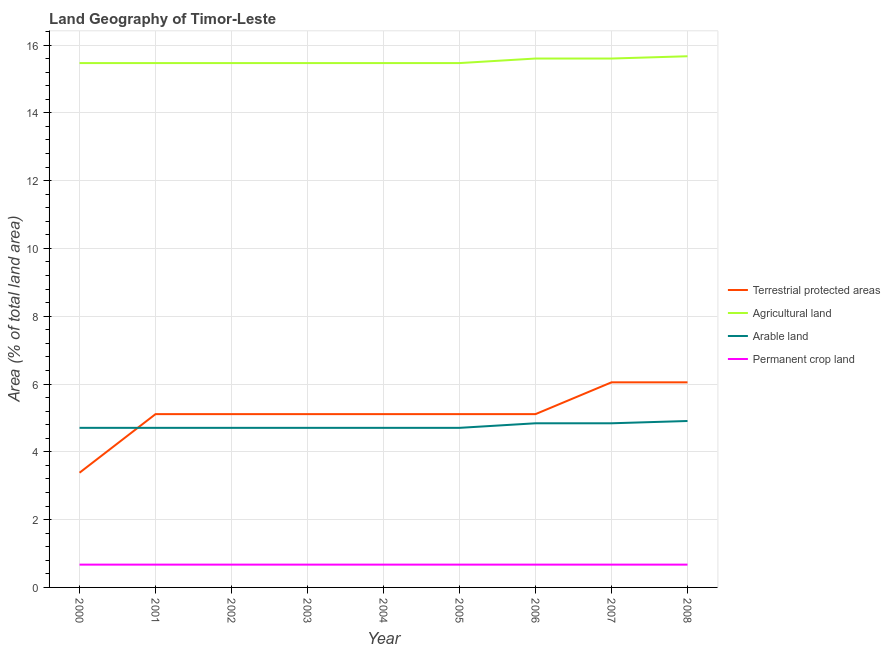How many different coloured lines are there?
Make the answer very short. 4. Is the number of lines equal to the number of legend labels?
Provide a succinct answer. Yes. What is the percentage of area under permanent crop land in 2001?
Your response must be concise. 0.67. Across all years, what is the maximum percentage of area under arable land?
Your response must be concise. 4.91. Across all years, what is the minimum percentage of area under agricultural land?
Give a very brief answer. 15.47. In which year was the percentage of land under terrestrial protection maximum?
Give a very brief answer. 2007. What is the total percentage of land under terrestrial protection in the graph?
Make the answer very short. 46.16. What is the difference between the percentage of land under terrestrial protection in 2000 and that in 2006?
Provide a short and direct response. -1.73. What is the difference between the percentage of area under permanent crop land in 2004 and the percentage of land under terrestrial protection in 2005?
Offer a terse response. -4.44. What is the average percentage of area under permanent crop land per year?
Your response must be concise. 0.67. In the year 2000, what is the difference between the percentage of area under arable land and percentage of area under permanent crop land?
Offer a very short reply. 4.03. What is the ratio of the percentage of area under agricultural land in 2007 to that in 2008?
Ensure brevity in your answer.  1. Is the percentage of area under permanent crop land in 2002 less than that in 2006?
Offer a terse response. No. Is the difference between the percentage of land under terrestrial protection in 2001 and 2005 greater than the difference between the percentage of area under agricultural land in 2001 and 2005?
Your response must be concise. No. What is the difference between the highest and the second highest percentage of area under permanent crop land?
Provide a succinct answer. 0. What is the difference between the highest and the lowest percentage of area under agricultural land?
Keep it short and to the point. 0.2. In how many years, is the percentage of area under permanent crop land greater than the average percentage of area under permanent crop land taken over all years?
Provide a short and direct response. 0. Is it the case that in every year, the sum of the percentage of area under arable land and percentage of land under terrestrial protection is greater than the sum of percentage of area under permanent crop land and percentage of area under agricultural land?
Your answer should be very brief. No. Is the percentage of area under agricultural land strictly greater than the percentage of land under terrestrial protection over the years?
Your answer should be compact. Yes. How many lines are there?
Provide a short and direct response. 4. How many years are there in the graph?
Give a very brief answer. 9. Are the values on the major ticks of Y-axis written in scientific E-notation?
Your answer should be very brief. No. Where does the legend appear in the graph?
Make the answer very short. Center right. How many legend labels are there?
Provide a short and direct response. 4. How are the legend labels stacked?
Offer a very short reply. Vertical. What is the title of the graph?
Your answer should be compact. Land Geography of Timor-Leste. What is the label or title of the X-axis?
Keep it short and to the point. Year. What is the label or title of the Y-axis?
Offer a terse response. Area (% of total land area). What is the Area (% of total land area) in Terrestrial protected areas in 2000?
Offer a very short reply. 3.38. What is the Area (% of total land area) of Agricultural land in 2000?
Provide a succinct answer. 15.47. What is the Area (% of total land area) in Arable land in 2000?
Make the answer very short. 4.71. What is the Area (% of total land area) of Permanent crop land in 2000?
Provide a succinct answer. 0.67. What is the Area (% of total land area) of Terrestrial protected areas in 2001?
Keep it short and to the point. 5.11. What is the Area (% of total land area) in Agricultural land in 2001?
Provide a succinct answer. 15.47. What is the Area (% of total land area) in Arable land in 2001?
Ensure brevity in your answer.  4.71. What is the Area (% of total land area) in Permanent crop land in 2001?
Your answer should be very brief. 0.67. What is the Area (% of total land area) of Terrestrial protected areas in 2002?
Make the answer very short. 5.11. What is the Area (% of total land area) in Agricultural land in 2002?
Ensure brevity in your answer.  15.47. What is the Area (% of total land area) in Arable land in 2002?
Provide a short and direct response. 4.71. What is the Area (% of total land area) of Permanent crop land in 2002?
Ensure brevity in your answer.  0.67. What is the Area (% of total land area) in Terrestrial protected areas in 2003?
Keep it short and to the point. 5.11. What is the Area (% of total land area) in Agricultural land in 2003?
Provide a succinct answer. 15.47. What is the Area (% of total land area) in Arable land in 2003?
Keep it short and to the point. 4.71. What is the Area (% of total land area) of Permanent crop land in 2003?
Make the answer very short. 0.67. What is the Area (% of total land area) of Terrestrial protected areas in 2004?
Your response must be concise. 5.11. What is the Area (% of total land area) of Agricultural land in 2004?
Your response must be concise. 15.47. What is the Area (% of total land area) of Arable land in 2004?
Keep it short and to the point. 4.71. What is the Area (% of total land area) of Permanent crop land in 2004?
Your answer should be compact. 0.67. What is the Area (% of total land area) in Terrestrial protected areas in 2005?
Provide a short and direct response. 5.11. What is the Area (% of total land area) of Agricultural land in 2005?
Provide a succinct answer. 15.47. What is the Area (% of total land area) in Arable land in 2005?
Make the answer very short. 4.71. What is the Area (% of total land area) in Permanent crop land in 2005?
Give a very brief answer. 0.67. What is the Area (% of total land area) in Terrestrial protected areas in 2006?
Provide a succinct answer. 5.11. What is the Area (% of total land area) of Agricultural land in 2006?
Provide a succinct answer. 15.6. What is the Area (% of total land area) in Arable land in 2006?
Make the answer very short. 4.84. What is the Area (% of total land area) of Permanent crop land in 2006?
Offer a terse response. 0.67. What is the Area (% of total land area) of Terrestrial protected areas in 2007?
Provide a succinct answer. 6.05. What is the Area (% of total land area) of Agricultural land in 2007?
Offer a terse response. 15.6. What is the Area (% of total land area) of Arable land in 2007?
Offer a terse response. 4.84. What is the Area (% of total land area) of Permanent crop land in 2007?
Your answer should be very brief. 0.67. What is the Area (% of total land area) of Terrestrial protected areas in 2008?
Provide a short and direct response. 6.05. What is the Area (% of total land area) of Agricultural land in 2008?
Your answer should be compact. 15.67. What is the Area (% of total land area) in Arable land in 2008?
Ensure brevity in your answer.  4.91. What is the Area (% of total land area) in Permanent crop land in 2008?
Your answer should be very brief. 0.67. Across all years, what is the maximum Area (% of total land area) in Terrestrial protected areas?
Provide a succinct answer. 6.05. Across all years, what is the maximum Area (% of total land area) of Agricultural land?
Give a very brief answer. 15.67. Across all years, what is the maximum Area (% of total land area) of Arable land?
Ensure brevity in your answer.  4.91. Across all years, what is the maximum Area (% of total land area) in Permanent crop land?
Offer a terse response. 0.67. Across all years, what is the minimum Area (% of total land area) of Terrestrial protected areas?
Your answer should be very brief. 3.38. Across all years, what is the minimum Area (% of total land area) in Agricultural land?
Provide a succinct answer. 15.47. Across all years, what is the minimum Area (% of total land area) of Arable land?
Give a very brief answer. 4.71. Across all years, what is the minimum Area (% of total land area) of Permanent crop land?
Keep it short and to the point. 0.67. What is the total Area (% of total land area) in Terrestrial protected areas in the graph?
Your response must be concise. 46.16. What is the total Area (% of total land area) of Agricultural land in the graph?
Provide a succinct answer. 139.68. What is the total Area (% of total land area) of Arable land in the graph?
Provide a succinct answer. 42.84. What is the total Area (% of total land area) of Permanent crop land in the graph?
Ensure brevity in your answer.  6.05. What is the difference between the Area (% of total land area) in Terrestrial protected areas in 2000 and that in 2001?
Offer a terse response. -1.73. What is the difference between the Area (% of total land area) of Arable land in 2000 and that in 2001?
Make the answer very short. 0. What is the difference between the Area (% of total land area) of Permanent crop land in 2000 and that in 2001?
Keep it short and to the point. 0. What is the difference between the Area (% of total land area) in Terrestrial protected areas in 2000 and that in 2002?
Offer a terse response. -1.73. What is the difference between the Area (% of total land area) in Arable land in 2000 and that in 2002?
Your answer should be compact. 0. What is the difference between the Area (% of total land area) of Permanent crop land in 2000 and that in 2002?
Your answer should be compact. 0. What is the difference between the Area (% of total land area) in Terrestrial protected areas in 2000 and that in 2003?
Your response must be concise. -1.73. What is the difference between the Area (% of total land area) of Terrestrial protected areas in 2000 and that in 2004?
Ensure brevity in your answer.  -1.73. What is the difference between the Area (% of total land area) in Arable land in 2000 and that in 2004?
Your answer should be very brief. 0. What is the difference between the Area (% of total land area) in Terrestrial protected areas in 2000 and that in 2005?
Give a very brief answer. -1.73. What is the difference between the Area (% of total land area) in Agricultural land in 2000 and that in 2005?
Give a very brief answer. 0. What is the difference between the Area (% of total land area) of Arable land in 2000 and that in 2005?
Keep it short and to the point. 0. What is the difference between the Area (% of total land area) in Terrestrial protected areas in 2000 and that in 2006?
Offer a very short reply. -1.73. What is the difference between the Area (% of total land area) in Agricultural land in 2000 and that in 2006?
Give a very brief answer. -0.13. What is the difference between the Area (% of total land area) in Arable land in 2000 and that in 2006?
Give a very brief answer. -0.13. What is the difference between the Area (% of total land area) in Permanent crop land in 2000 and that in 2006?
Your response must be concise. 0. What is the difference between the Area (% of total land area) of Terrestrial protected areas in 2000 and that in 2007?
Offer a very short reply. -2.67. What is the difference between the Area (% of total land area) of Agricultural land in 2000 and that in 2007?
Your answer should be compact. -0.13. What is the difference between the Area (% of total land area) of Arable land in 2000 and that in 2007?
Your answer should be compact. -0.13. What is the difference between the Area (% of total land area) of Terrestrial protected areas in 2000 and that in 2008?
Make the answer very short. -2.67. What is the difference between the Area (% of total land area) of Agricultural land in 2000 and that in 2008?
Make the answer very short. -0.2. What is the difference between the Area (% of total land area) of Arable land in 2000 and that in 2008?
Offer a terse response. -0.2. What is the difference between the Area (% of total land area) of Terrestrial protected areas in 2001 and that in 2002?
Your answer should be very brief. 0. What is the difference between the Area (% of total land area) in Agricultural land in 2001 and that in 2003?
Give a very brief answer. 0. What is the difference between the Area (% of total land area) in Permanent crop land in 2001 and that in 2003?
Provide a short and direct response. 0. What is the difference between the Area (% of total land area) of Terrestrial protected areas in 2001 and that in 2004?
Give a very brief answer. 0. What is the difference between the Area (% of total land area) of Arable land in 2001 and that in 2004?
Your answer should be very brief. 0. What is the difference between the Area (% of total land area) of Permanent crop land in 2001 and that in 2004?
Offer a terse response. 0. What is the difference between the Area (% of total land area) in Agricultural land in 2001 and that in 2005?
Make the answer very short. 0. What is the difference between the Area (% of total land area) in Permanent crop land in 2001 and that in 2005?
Your response must be concise. 0. What is the difference between the Area (% of total land area) of Agricultural land in 2001 and that in 2006?
Keep it short and to the point. -0.13. What is the difference between the Area (% of total land area) of Arable land in 2001 and that in 2006?
Offer a very short reply. -0.13. What is the difference between the Area (% of total land area) of Terrestrial protected areas in 2001 and that in 2007?
Offer a very short reply. -0.94. What is the difference between the Area (% of total land area) of Agricultural land in 2001 and that in 2007?
Provide a succinct answer. -0.13. What is the difference between the Area (% of total land area) in Arable land in 2001 and that in 2007?
Your response must be concise. -0.13. What is the difference between the Area (% of total land area) of Permanent crop land in 2001 and that in 2007?
Your response must be concise. 0. What is the difference between the Area (% of total land area) in Terrestrial protected areas in 2001 and that in 2008?
Your answer should be very brief. -0.94. What is the difference between the Area (% of total land area) in Agricultural land in 2001 and that in 2008?
Make the answer very short. -0.2. What is the difference between the Area (% of total land area) in Arable land in 2001 and that in 2008?
Your response must be concise. -0.2. What is the difference between the Area (% of total land area) in Permanent crop land in 2001 and that in 2008?
Provide a succinct answer. 0. What is the difference between the Area (% of total land area) of Arable land in 2002 and that in 2003?
Your response must be concise. 0. What is the difference between the Area (% of total land area) in Terrestrial protected areas in 2002 and that in 2004?
Keep it short and to the point. 0. What is the difference between the Area (% of total land area) of Arable land in 2002 and that in 2004?
Offer a very short reply. 0. What is the difference between the Area (% of total land area) of Agricultural land in 2002 and that in 2005?
Your answer should be very brief. 0. What is the difference between the Area (% of total land area) in Agricultural land in 2002 and that in 2006?
Your response must be concise. -0.13. What is the difference between the Area (% of total land area) of Arable land in 2002 and that in 2006?
Provide a short and direct response. -0.13. What is the difference between the Area (% of total land area) of Permanent crop land in 2002 and that in 2006?
Give a very brief answer. 0. What is the difference between the Area (% of total land area) in Terrestrial protected areas in 2002 and that in 2007?
Give a very brief answer. -0.94. What is the difference between the Area (% of total land area) of Agricultural land in 2002 and that in 2007?
Provide a succinct answer. -0.13. What is the difference between the Area (% of total land area) in Arable land in 2002 and that in 2007?
Ensure brevity in your answer.  -0.13. What is the difference between the Area (% of total land area) of Terrestrial protected areas in 2002 and that in 2008?
Give a very brief answer. -0.94. What is the difference between the Area (% of total land area) in Agricultural land in 2002 and that in 2008?
Offer a terse response. -0.2. What is the difference between the Area (% of total land area) of Arable land in 2002 and that in 2008?
Your response must be concise. -0.2. What is the difference between the Area (% of total land area) in Permanent crop land in 2003 and that in 2004?
Ensure brevity in your answer.  0. What is the difference between the Area (% of total land area) in Terrestrial protected areas in 2003 and that in 2005?
Offer a very short reply. 0. What is the difference between the Area (% of total land area) in Agricultural land in 2003 and that in 2005?
Offer a terse response. 0. What is the difference between the Area (% of total land area) in Terrestrial protected areas in 2003 and that in 2006?
Keep it short and to the point. 0. What is the difference between the Area (% of total land area) of Agricultural land in 2003 and that in 2006?
Make the answer very short. -0.13. What is the difference between the Area (% of total land area) of Arable land in 2003 and that in 2006?
Provide a succinct answer. -0.13. What is the difference between the Area (% of total land area) of Terrestrial protected areas in 2003 and that in 2007?
Your answer should be very brief. -0.94. What is the difference between the Area (% of total land area) in Agricultural land in 2003 and that in 2007?
Provide a short and direct response. -0.13. What is the difference between the Area (% of total land area) of Arable land in 2003 and that in 2007?
Keep it short and to the point. -0.13. What is the difference between the Area (% of total land area) in Permanent crop land in 2003 and that in 2007?
Offer a very short reply. 0. What is the difference between the Area (% of total land area) in Terrestrial protected areas in 2003 and that in 2008?
Provide a succinct answer. -0.94. What is the difference between the Area (% of total land area) in Agricultural land in 2003 and that in 2008?
Provide a short and direct response. -0.2. What is the difference between the Area (% of total land area) of Arable land in 2003 and that in 2008?
Ensure brevity in your answer.  -0.2. What is the difference between the Area (% of total land area) in Terrestrial protected areas in 2004 and that in 2005?
Make the answer very short. 0. What is the difference between the Area (% of total land area) in Permanent crop land in 2004 and that in 2005?
Provide a short and direct response. 0. What is the difference between the Area (% of total land area) of Agricultural land in 2004 and that in 2006?
Your response must be concise. -0.13. What is the difference between the Area (% of total land area) of Arable land in 2004 and that in 2006?
Make the answer very short. -0.13. What is the difference between the Area (% of total land area) of Terrestrial protected areas in 2004 and that in 2007?
Make the answer very short. -0.94. What is the difference between the Area (% of total land area) in Agricultural land in 2004 and that in 2007?
Your answer should be compact. -0.13. What is the difference between the Area (% of total land area) in Arable land in 2004 and that in 2007?
Provide a short and direct response. -0.13. What is the difference between the Area (% of total land area) in Permanent crop land in 2004 and that in 2007?
Ensure brevity in your answer.  0. What is the difference between the Area (% of total land area) of Terrestrial protected areas in 2004 and that in 2008?
Keep it short and to the point. -0.94. What is the difference between the Area (% of total land area) in Agricultural land in 2004 and that in 2008?
Make the answer very short. -0.2. What is the difference between the Area (% of total land area) of Arable land in 2004 and that in 2008?
Give a very brief answer. -0.2. What is the difference between the Area (% of total land area) in Permanent crop land in 2004 and that in 2008?
Offer a terse response. 0. What is the difference between the Area (% of total land area) of Terrestrial protected areas in 2005 and that in 2006?
Your answer should be compact. 0. What is the difference between the Area (% of total land area) in Agricultural land in 2005 and that in 2006?
Provide a succinct answer. -0.13. What is the difference between the Area (% of total land area) in Arable land in 2005 and that in 2006?
Offer a terse response. -0.13. What is the difference between the Area (% of total land area) of Terrestrial protected areas in 2005 and that in 2007?
Provide a short and direct response. -0.94. What is the difference between the Area (% of total land area) of Agricultural land in 2005 and that in 2007?
Offer a very short reply. -0.13. What is the difference between the Area (% of total land area) in Arable land in 2005 and that in 2007?
Give a very brief answer. -0.13. What is the difference between the Area (% of total land area) in Permanent crop land in 2005 and that in 2007?
Provide a short and direct response. 0. What is the difference between the Area (% of total land area) in Terrestrial protected areas in 2005 and that in 2008?
Make the answer very short. -0.94. What is the difference between the Area (% of total land area) of Agricultural land in 2005 and that in 2008?
Provide a short and direct response. -0.2. What is the difference between the Area (% of total land area) in Arable land in 2005 and that in 2008?
Give a very brief answer. -0.2. What is the difference between the Area (% of total land area) of Terrestrial protected areas in 2006 and that in 2007?
Provide a short and direct response. -0.94. What is the difference between the Area (% of total land area) in Arable land in 2006 and that in 2007?
Keep it short and to the point. 0. What is the difference between the Area (% of total land area) in Permanent crop land in 2006 and that in 2007?
Your answer should be very brief. 0. What is the difference between the Area (% of total land area) of Terrestrial protected areas in 2006 and that in 2008?
Your response must be concise. -0.94. What is the difference between the Area (% of total land area) in Agricultural land in 2006 and that in 2008?
Your response must be concise. -0.07. What is the difference between the Area (% of total land area) in Arable land in 2006 and that in 2008?
Provide a short and direct response. -0.07. What is the difference between the Area (% of total land area) in Terrestrial protected areas in 2007 and that in 2008?
Your response must be concise. 0. What is the difference between the Area (% of total land area) in Agricultural land in 2007 and that in 2008?
Make the answer very short. -0.07. What is the difference between the Area (% of total land area) of Arable land in 2007 and that in 2008?
Make the answer very short. -0.07. What is the difference between the Area (% of total land area) in Terrestrial protected areas in 2000 and the Area (% of total land area) in Agricultural land in 2001?
Ensure brevity in your answer.  -12.08. What is the difference between the Area (% of total land area) of Terrestrial protected areas in 2000 and the Area (% of total land area) of Arable land in 2001?
Provide a short and direct response. -1.32. What is the difference between the Area (% of total land area) of Terrestrial protected areas in 2000 and the Area (% of total land area) of Permanent crop land in 2001?
Your answer should be compact. 2.71. What is the difference between the Area (% of total land area) in Agricultural land in 2000 and the Area (% of total land area) in Arable land in 2001?
Provide a short and direct response. 10.76. What is the difference between the Area (% of total land area) in Agricultural land in 2000 and the Area (% of total land area) in Permanent crop land in 2001?
Provide a succinct answer. 14.79. What is the difference between the Area (% of total land area) of Arable land in 2000 and the Area (% of total land area) of Permanent crop land in 2001?
Provide a short and direct response. 4.04. What is the difference between the Area (% of total land area) of Terrestrial protected areas in 2000 and the Area (% of total land area) of Agricultural land in 2002?
Ensure brevity in your answer.  -12.08. What is the difference between the Area (% of total land area) in Terrestrial protected areas in 2000 and the Area (% of total land area) in Arable land in 2002?
Offer a terse response. -1.32. What is the difference between the Area (% of total land area) in Terrestrial protected areas in 2000 and the Area (% of total land area) in Permanent crop land in 2002?
Provide a succinct answer. 2.71. What is the difference between the Area (% of total land area) in Agricultural land in 2000 and the Area (% of total land area) in Arable land in 2002?
Your answer should be compact. 10.76. What is the difference between the Area (% of total land area) in Agricultural land in 2000 and the Area (% of total land area) in Permanent crop land in 2002?
Offer a terse response. 14.79. What is the difference between the Area (% of total land area) in Arable land in 2000 and the Area (% of total land area) in Permanent crop land in 2002?
Offer a very short reply. 4.04. What is the difference between the Area (% of total land area) of Terrestrial protected areas in 2000 and the Area (% of total land area) of Agricultural land in 2003?
Ensure brevity in your answer.  -12.08. What is the difference between the Area (% of total land area) of Terrestrial protected areas in 2000 and the Area (% of total land area) of Arable land in 2003?
Your response must be concise. -1.32. What is the difference between the Area (% of total land area) of Terrestrial protected areas in 2000 and the Area (% of total land area) of Permanent crop land in 2003?
Provide a short and direct response. 2.71. What is the difference between the Area (% of total land area) of Agricultural land in 2000 and the Area (% of total land area) of Arable land in 2003?
Your answer should be very brief. 10.76. What is the difference between the Area (% of total land area) of Agricultural land in 2000 and the Area (% of total land area) of Permanent crop land in 2003?
Your answer should be compact. 14.79. What is the difference between the Area (% of total land area) in Arable land in 2000 and the Area (% of total land area) in Permanent crop land in 2003?
Make the answer very short. 4.04. What is the difference between the Area (% of total land area) in Terrestrial protected areas in 2000 and the Area (% of total land area) in Agricultural land in 2004?
Ensure brevity in your answer.  -12.08. What is the difference between the Area (% of total land area) in Terrestrial protected areas in 2000 and the Area (% of total land area) in Arable land in 2004?
Your answer should be very brief. -1.32. What is the difference between the Area (% of total land area) in Terrestrial protected areas in 2000 and the Area (% of total land area) in Permanent crop land in 2004?
Offer a terse response. 2.71. What is the difference between the Area (% of total land area) in Agricultural land in 2000 and the Area (% of total land area) in Arable land in 2004?
Provide a short and direct response. 10.76. What is the difference between the Area (% of total land area) of Agricultural land in 2000 and the Area (% of total land area) of Permanent crop land in 2004?
Ensure brevity in your answer.  14.79. What is the difference between the Area (% of total land area) in Arable land in 2000 and the Area (% of total land area) in Permanent crop land in 2004?
Give a very brief answer. 4.04. What is the difference between the Area (% of total land area) of Terrestrial protected areas in 2000 and the Area (% of total land area) of Agricultural land in 2005?
Offer a very short reply. -12.08. What is the difference between the Area (% of total land area) of Terrestrial protected areas in 2000 and the Area (% of total land area) of Arable land in 2005?
Give a very brief answer. -1.32. What is the difference between the Area (% of total land area) of Terrestrial protected areas in 2000 and the Area (% of total land area) of Permanent crop land in 2005?
Your response must be concise. 2.71. What is the difference between the Area (% of total land area) of Agricultural land in 2000 and the Area (% of total land area) of Arable land in 2005?
Ensure brevity in your answer.  10.76. What is the difference between the Area (% of total land area) of Agricultural land in 2000 and the Area (% of total land area) of Permanent crop land in 2005?
Your response must be concise. 14.79. What is the difference between the Area (% of total land area) in Arable land in 2000 and the Area (% of total land area) in Permanent crop land in 2005?
Your answer should be compact. 4.04. What is the difference between the Area (% of total land area) in Terrestrial protected areas in 2000 and the Area (% of total land area) in Agricultural land in 2006?
Your answer should be compact. -12.22. What is the difference between the Area (% of total land area) of Terrestrial protected areas in 2000 and the Area (% of total land area) of Arable land in 2006?
Make the answer very short. -1.46. What is the difference between the Area (% of total land area) of Terrestrial protected areas in 2000 and the Area (% of total land area) of Permanent crop land in 2006?
Make the answer very short. 2.71. What is the difference between the Area (% of total land area) of Agricultural land in 2000 and the Area (% of total land area) of Arable land in 2006?
Keep it short and to the point. 10.63. What is the difference between the Area (% of total land area) in Agricultural land in 2000 and the Area (% of total land area) in Permanent crop land in 2006?
Offer a terse response. 14.79. What is the difference between the Area (% of total land area) of Arable land in 2000 and the Area (% of total land area) of Permanent crop land in 2006?
Ensure brevity in your answer.  4.04. What is the difference between the Area (% of total land area) of Terrestrial protected areas in 2000 and the Area (% of total land area) of Agricultural land in 2007?
Provide a succinct answer. -12.22. What is the difference between the Area (% of total land area) in Terrestrial protected areas in 2000 and the Area (% of total land area) in Arable land in 2007?
Your response must be concise. -1.46. What is the difference between the Area (% of total land area) of Terrestrial protected areas in 2000 and the Area (% of total land area) of Permanent crop land in 2007?
Give a very brief answer. 2.71. What is the difference between the Area (% of total land area) of Agricultural land in 2000 and the Area (% of total land area) of Arable land in 2007?
Give a very brief answer. 10.63. What is the difference between the Area (% of total land area) in Agricultural land in 2000 and the Area (% of total land area) in Permanent crop land in 2007?
Your answer should be very brief. 14.79. What is the difference between the Area (% of total land area) of Arable land in 2000 and the Area (% of total land area) of Permanent crop land in 2007?
Your answer should be compact. 4.04. What is the difference between the Area (% of total land area) of Terrestrial protected areas in 2000 and the Area (% of total land area) of Agricultural land in 2008?
Your answer should be very brief. -12.29. What is the difference between the Area (% of total land area) of Terrestrial protected areas in 2000 and the Area (% of total land area) of Arable land in 2008?
Your answer should be very brief. -1.53. What is the difference between the Area (% of total land area) in Terrestrial protected areas in 2000 and the Area (% of total land area) in Permanent crop land in 2008?
Give a very brief answer. 2.71. What is the difference between the Area (% of total land area) in Agricultural land in 2000 and the Area (% of total land area) in Arable land in 2008?
Your answer should be compact. 10.56. What is the difference between the Area (% of total land area) of Agricultural land in 2000 and the Area (% of total land area) of Permanent crop land in 2008?
Provide a succinct answer. 14.79. What is the difference between the Area (% of total land area) in Arable land in 2000 and the Area (% of total land area) in Permanent crop land in 2008?
Your answer should be very brief. 4.04. What is the difference between the Area (% of total land area) of Terrestrial protected areas in 2001 and the Area (% of total land area) of Agricultural land in 2002?
Give a very brief answer. -10.36. What is the difference between the Area (% of total land area) of Terrestrial protected areas in 2001 and the Area (% of total land area) of Arable land in 2002?
Provide a short and direct response. 0.4. What is the difference between the Area (% of total land area) of Terrestrial protected areas in 2001 and the Area (% of total land area) of Permanent crop land in 2002?
Give a very brief answer. 4.44. What is the difference between the Area (% of total land area) of Agricultural land in 2001 and the Area (% of total land area) of Arable land in 2002?
Give a very brief answer. 10.76. What is the difference between the Area (% of total land area) in Agricultural land in 2001 and the Area (% of total land area) in Permanent crop land in 2002?
Ensure brevity in your answer.  14.79. What is the difference between the Area (% of total land area) in Arable land in 2001 and the Area (% of total land area) in Permanent crop land in 2002?
Provide a short and direct response. 4.04. What is the difference between the Area (% of total land area) of Terrestrial protected areas in 2001 and the Area (% of total land area) of Agricultural land in 2003?
Your answer should be very brief. -10.36. What is the difference between the Area (% of total land area) in Terrestrial protected areas in 2001 and the Area (% of total land area) in Arable land in 2003?
Keep it short and to the point. 0.4. What is the difference between the Area (% of total land area) in Terrestrial protected areas in 2001 and the Area (% of total land area) in Permanent crop land in 2003?
Your answer should be compact. 4.44. What is the difference between the Area (% of total land area) of Agricultural land in 2001 and the Area (% of total land area) of Arable land in 2003?
Your answer should be compact. 10.76. What is the difference between the Area (% of total land area) of Agricultural land in 2001 and the Area (% of total land area) of Permanent crop land in 2003?
Keep it short and to the point. 14.79. What is the difference between the Area (% of total land area) of Arable land in 2001 and the Area (% of total land area) of Permanent crop land in 2003?
Your answer should be compact. 4.04. What is the difference between the Area (% of total land area) in Terrestrial protected areas in 2001 and the Area (% of total land area) in Agricultural land in 2004?
Provide a short and direct response. -10.36. What is the difference between the Area (% of total land area) of Terrestrial protected areas in 2001 and the Area (% of total land area) of Arable land in 2004?
Provide a short and direct response. 0.4. What is the difference between the Area (% of total land area) of Terrestrial protected areas in 2001 and the Area (% of total land area) of Permanent crop land in 2004?
Provide a succinct answer. 4.44. What is the difference between the Area (% of total land area) in Agricultural land in 2001 and the Area (% of total land area) in Arable land in 2004?
Your response must be concise. 10.76. What is the difference between the Area (% of total land area) of Agricultural land in 2001 and the Area (% of total land area) of Permanent crop land in 2004?
Your answer should be compact. 14.79. What is the difference between the Area (% of total land area) of Arable land in 2001 and the Area (% of total land area) of Permanent crop land in 2004?
Your answer should be compact. 4.04. What is the difference between the Area (% of total land area) in Terrestrial protected areas in 2001 and the Area (% of total land area) in Agricultural land in 2005?
Give a very brief answer. -10.36. What is the difference between the Area (% of total land area) in Terrestrial protected areas in 2001 and the Area (% of total land area) in Arable land in 2005?
Provide a short and direct response. 0.4. What is the difference between the Area (% of total land area) of Terrestrial protected areas in 2001 and the Area (% of total land area) of Permanent crop land in 2005?
Your answer should be very brief. 4.44. What is the difference between the Area (% of total land area) of Agricultural land in 2001 and the Area (% of total land area) of Arable land in 2005?
Offer a very short reply. 10.76. What is the difference between the Area (% of total land area) in Agricultural land in 2001 and the Area (% of total land area) in Permanent crop land in 2005?
Offer a very short reply. 14.79. What is the difference between the Area (% of total land area) of Arable land in 2001 and the Area (% of total land area) of Permanent crop land in 2005?
Keep it short and to the point. 4.04. What is the difference between the Area (% of total land area) in Terrestrial protected areas in 2001 and the Area (% of total land area) in Agricultural land in 2006?
Keep it short and to the point. -10.49. What is the difference between the Area (% of total land area) in Terrestrial protected areas in 2001 and the Area (% of total land area) in Arable land in 2006?
Offer a very short reply. 0.27. What is the difference between the Area (% of total land area) of Terrestrial protected areas in 2001 and the Area (% of total land area) of Permanent crop land in 2006?
Give a very brief answer. 4.44. What is the difference between the Area (% of total land area) of Agricultural land in 2001 and the Area (% of total land area) of Arable land in 2006?
Your answer should be very brief. 10.63. What is the difference between the Area (% of total land area) of Agricultural land in 2001 and the Area (% of total land area) of Permanent crop land in 2006?
Offer a terse response. 14.79. What is the difference between the Area (% of total land area) in Arable land in 2001 and the Area (% of total land area) in Permanent crop land in 2006?
Provide a short and direct response. 4.04. What is the difference between the Area (% of total land area) of Terrestrial protected areas in 2001 and the Area (% of total land area) of Agricultural land in 2007?
Your response must be concise. -10.49. What is the difference between the Area (% of total land area) of Terrestrial protected areas in 2001 and the Area (% of total land area) of Arable land in 2007?
Offer a very short reply. 0.27. What is the difference between the Area (% of total land area) in Terrestrial protected areas in 2001 and the Area (% of total land area) in Permanent crop land in 2007?
Give a very brief answer. 4.44. What is the difference between the Area (% of total land area) in Agricultural land in 2001 and the Area (% of total land area) in Arable land in 2007?
Make the answer very short. 10.63. What is the difference between the Area (% of total land area) in Agricultural land in 2001 and the Area (% of total land area) in Permanent crop land in 2007?
Ensure brevity in your answer.  14.79. What is the difference between the Area (% of total land area) in Arable land in 2001 and the Area (% of total land area) in Permanent crop land in 2007?
Provide a succinct answer. 4.04. What is the difference between the Area (% of total land area) of Terrestrial protected areas in 2001 and the Area (% of total land area) of Agricultural land in 2008?
Provide a succinct answer. -10.56. What is the difference between the Area (% of total land area) in Terrestrial protected areas in 2001 and the Area (% of total land area) in Arable land in 2008?
Ensure brevity in your answer.  0.2. What is the difference between the Area (% of total land area) in Terrestrial protected areas in 2001 and the Area (% of total land area) in Permanent crop land in 2008?
Your response must be concise. 4.44. What is the difference between the Area (% of total land area) in Agricultural land in 2001 and the Area (% of total land area) in Arable land in 2008?
Keep it short and to the point. 10.56. What is the difference between the Area (% of total land area) in Agricultural land in 2001 and the Area (% of total land area) in Permanent crop land in 2008?
Provide a short and direct response. 14.79. What is the difference between the Area (% of total land area) of Arable land in 2001 and the Area (% of total land area) of Permanent crop land in 2008?
Keep it short and to the point. 4.04. What is the difference between the Area (% of total land area) of Terrestrial protected areas in 2002 and the Area (% of total land area) of Agricultural land in 2003?
Ensure brevity in your answer.  -10.36. What is the difference between the Area (% of total land area) of Terrestrial protected areas in 2002 and the Area (% of total land area) of Arable land in 2003?
Your answer should be very brief. 0.4. What is the difference between the Area (% of total land area) of Terrestrial protected areas in 2002 and the Area (% of total land area) of Permanent crop land in 2003?
Provide a succinct answer. 4.44. What is the difference between the Area (% of total land area) of Agricultural land in 2002 and the Area (% of total land area) of Arable land in 2003?
Provide a succinct answer. 10.76. What is the difference between the Area (% of total land area) in Agricultural land in 2002 and the Area (% of total land area) in Permanent crop land in 2003?
Your answer should be very brief. 14.79. What is the difference between the Area (% of total land area) of Arable land in 2002 and the Area (% of total land area) of Permanent crop land in 2003?
Give a very brief answer. 4.04. What is the difference between the Area (% of total land area) in Terrestrial protected areas in 2002 and the Area (% of total land area) in Agricultural land in 2004?
Your answer should be compact. -10.36. What is the difference between the Area (% of total land area) in Terrestrial protected areas in 2002 and the Area (% of total land area) in Arable land in 2004?
Provide a succinct answer. 0.4. What is the difference between the Area (% of total land area) in Terrestrial protected areas in 2002 and the Area (% of total land area) in Permanent crop land in 2004?
Give a very brief answer. 4.44. What is the difference between the Area (% of total land area) of Agricultural land in 2002 and the Area (% of total land area) of Arable land in 2004?
Give a very brief answer. 10.76. What is the difference between the Area (% of total land area) of Agricultural land in 2002 and the Area (% of total land area) of Permanent crop land in 2004?
Offer a terse response. 14.79. What is the difference between the Area (% of total land area) of Arable land in 2002 and the Area (% of total land area) of Permanent crop land in 2004?
Ensure brevity in your answer.  4.04. What is the difference between the Area (% of total land area) in Terrestrial protected areas in 2002 and the Area (% of total land area) in Agricultural land in 2005?
Provide a short and direct response. -10.36. What is the difference between the Area (% of total land area) in Terrestrial protected areas in 2002 and the Area (% of total land area) in Arable land in 2005?
Your answer should be very brief. 0.4. What is the difference between the Area (% of total land area) of Terrestrial protected areas in 2002 and the Area (% of total land area) of Permanent crop land in 2005?
Give a very brief answer. 4.44. What is the difference between the Area (% of total land area) of Agricultural land in 2002 and the Area (% of total land area) of Arable land in 2005?
Ensure brevity in your answer.  10.76. What is the difference between the Area (% of total land area) in Agricultural land in 2002 and the Area (% of total land area) in Permanent crop land in 2005?
Give a very brief answer. 14.79. What is the difference between the Area (% of total land area) of Arable land in 2002 and the Area (% of total land area) of Permanent crop land in 2005?
Give a very brief answer. 4.04. What is the difference between the Area (% of total land area) of Terrestrial protected areas in 2002 and the Area (% of total land area) of Agricultural land in 2006?
Provide a short and direct response. -10.49. What is the difference between the Area (% of total land area) in Terrestrial protected areas in 2002 and the Area (% of total land area) in Arable land in 2006?
Keep it short and to the point. 0.27. What is the difference between the Area (% of total land area) of Terrestrial protected areas in 2002 and the Area (% of total land area) of Permanent crop land in 2006?
Make the answer very short. 4.44. What is the difference between the Area (% of total land area) of Agricultural land in 2002 and the Area (% of total land area) of Arable land in 2006?
Your answer should be compact. 10.63. What is the difference between the Area (% of total land area) in Agricultural land in 2002 and the Area (% of total land area) in Permanent crop land in 2006?
Offer a terse response. 14.79. What is the difference between the Area (% of total land area) in Arable land in 2002 and the Area (% of total land area) in Permanent crop land in 2006?
Your answer should be compact. 4.04. What is the difference between the Area (% of total land area) in Terrestrial protected areas in 2002 and the Area (% of total land area) in Agricultural land in 2007?
Keep it short and to the point. -10.49. What is the difference between the Area (% of total land area) in Terrestrial protected areas in 2002 and the Area (% of total land area) in Arable land in 2007?
Offer a very short reply. 0.27. What is the difference between the Area (% of total land area) in Terrestrial protected areas in 2002 and the Area (% of total land area) in Permanent crop land in 2007?
Offer a very short reply. 4.44. What is the difference between the Area (% of total land area) in Agricultural land in 2002 and the Area (% of total land area) in Arable land in 2007?
Keep it short and to the point. 10.63. What is the difference between the Area (% of total land area) of Agricultural land in 2002 and the Area (% of total land area) of Permanent crop land in 2007?
Ensure brevity in your answer.  14.79. What is the difference between the Area (% of total land area) of Arable land in 2002 and the Area (% of total land area) of Permanent crop land in 2007?
Your response must be concise. 4.04. What is the difference between the Area (% of total land area) in Terrestrial protected areas in 2002 and the Area (% of total land area) in Agricultural land in 2008?
Give a very brief answer. -10.56. What is the difference between the Area (% of total land area) in Terrestrial protected areas in 2002 and the Area (% of total land area) in Arable land in 2008?
Your response must be concise. 0.2. What is the difference between the Area (% of total land area) in Terrestrial protected areas in 2002 and the Area (% of total land area) in Permanent crop land in 2008?
Provide a short and direct response. 4.44. What is the difference between the Area (% of total land area) of Agricultural land in 2002 and the Area (% of total land area) of Arable land in 2008?
Your answer should be compact. 10.56. What is the difference between the Area (% of total land area) in Agricultural land in 2002 and the Area (% of total land area) in Permanent crop land in 2008?
Your answer should be very brief. 14.79. What is the difference between the Area (% of total land area) in Arable land in 2002 and the Area (% of total land area) in Permanent crop land in 2008?
Ensure brevity in your answer.  4.04. What is the difference between the Area (% of total land area) of Terrestrial protected areas in 2003 and the Area (% of total land area) of Agricultural land in 2004?
Offer a very short reply. -10.36. What is the difference between the Area (% of total land area) in Terrestrial protected areas in 2003 and the Area (% of total land area) in Arable land in 2004?
Your answer should be compact. 0.4. What is the difference between the Area (% of total land area) of Terrestrial protected areas in 2003 and the Area (% of total land area) of Permanent crop land in 2004?
Make the answer very short. 4.44. What is the difference between the Area (% of total land area) of Agricultural land in 2003 and the Area (% of total land area) of Arable land in 2004?
Offer a very short reply. 10.76. What is the difference between the Area (% of total land area) of Agricultural land in 2003 and the Area (% of total land area) of Permanent crop land in 2004?
Offer a terse response. 14.79. What is the difference between the Area (% of total land area) of Arable land in 2003 and the Area (% of total land area) of Permanent crop land in 2004?
Keep it short and to the point. 4.04. What is the difference between the Area (% of total land area) in Terrestrial protected areas in 2003 and the Area (% of total land area) in Agricultural land in 2005?
Your answer should be compact. -10.36. What is the difference between the Area (% of total land area) in Terrestrial protected areas in 2003 and the Area (% of total land area) in Arable land in 2005?
Provide a succinct answer. 0.4. What is the difference between the Area (% of total land area) of Terrestrial protected areas in 2003 and the Area (% of total land area) of Permanent crop land in 2005?
Offer a terse response. 4.44. What is the difference between the Area (% of total land area) of Agricultural land in 2003 and the Area (% of total land area) of Arable land in 2005?
Your response must be concise. 10.76. What is the difference between the Area (% of total land area) of Agricultural land in 2003 and the Area (% of total land area) of Permanent crop land in 2005?
Your response must be concise. 14.79. What is the difference between the Area (% of total land area) in Arable land in 2003 and the Area (% of total land area) in Permanent crop land in 2005?
Keep it short and to the point. 4.04. What is the difference between the Area (% of total land area) in Terrestrial protected areas in 2003 and the Area (% of total land area) in Agricultural land in 2006?
Keep it short and to the point. -10.49. What is the difference between the Area (% of total land area) in Terrestrial protected areas in 2003 and the Area (% of total land area) in Arable land in 2006?
Give a very brief answer. 0.27. What is the difference between the Area (% of total land area) of Terrestrial protected areas in 2003 and the Area (% of total land area) of Permanent crop land in 2006?
Your response must be concise. 4.44. What is the difference between the Area (% of total land area) in Agricultural land in 2003 and the Area (% of total land area) in Arable land in 2006?
Offer a terse response. 10.63. What is the difference between the Area (% of total land area) of Agricultural land in 2003 and the Area (% of total land area) of Permanent crop land in 2006?
Keep it short and to the point. 14.79. What is the difference between the Area (% of total land area) in Arable land in 2003 and the Area (% of total land area) in Permanent crop land in 2006?
Your answer should be compact. 4.04. What is the difference between the Area (% of total land area) in Terrestrial protected areas in 2003 and the Area (% of total land area) in Agricultural land in 2007?
Provide a short and direct response. -10.49. What is the difference between the Area (% of total land area) in Terrestrial protected areas in 2003 and the Area (% of total land area) in Arable land in 2007?
Offer a terse response. 0.27. What is the difference between the Area (% of total land area) in Terrestrial protected areas in 2003 and the Area (% of total land area) in Permanent crop land in 2007?
Make the answer very short. 4.44. What is the difference between the Area (% of total land area) in Agricultural land in 2003 and the Area (% of total land area) in Arable land in 2007?
Keep it short and to the point. 10.63. What is the difference between the Area (% of total land area) in Agricultural land in 2003 and the Area (% of total land area) in Permanent crop land in 2007?
Provide a short and direct response. 14.79. What is the difference between the Area (% of total land area) in Arable land in 2003 and the Area (% of total land area) in Permanent crop land in 2007?
Ensure brevity in your answer.  4.04. What is the difference between the Area (% of total land area) in Terrestrial protected areas in 2003 and the Area (% of total land area) in Agricultural land in 2008?
Your response must be concise. -10.56. What is the difference between the Area (% of total land area) in Terrestrial protected areas in 2003 and the Area (% of total land area) in Arable land in 2008?
Your answer should be compact. 0.2. What is the difference between the Area (% of total land area) in Terrestrial protected areas in 2003 and the Area (% of total land area) in Permanent crop land in 2008?
Your response must be concise. 4.44. What is the difference between the Area (% of total land area) in Agricultural land in 2003 and the Area (% of total land area) in Arable land in 2008?
Offer a terse response. 10.56. What is the difference between the Area (% of total land area) of Agricultural land in 2003 and the Area (% of total land area) of Permanent crop land in 2008?
Provide a short and direct response. 14.79. What is the difference between the Area (% of total land area) of Arable land in 2003 and the Area (% of total land area) of Permanent crop land in 2008?
Provide a short and direct response. 4.04. What is the difference between the Area (% of total land area) in Terrestrial protected areas in 2004 and the Area (% of total land area) in Agricultural land in 2005?
Give a very brief answer. -10.36. What is the difference between the Area (% of total land area) of Terrestrial protected areas in 2004 and the Area (% of total land area) of Arable land in 2005?
Your answer should be compact. 0.4. What is the difference between the Area (% of total land area) of Terrestrial protected areas in 2004 and the Area (% of total land area) of Permanent crop land in 2005?
Make the answer very short. 4.44. What is the difference between the Area (% of total land area) of Agricultural land in 2004 and the Area (% of total land area) of Arable land in 2005?
Make the answer very short. 10.76. What is the difference between the Area (% of total land area) of Agricultural land in 2004 and the Area (% of total land area) of Permanent crop land in 2005?
Your answer should be very brief. 14.79. What is the difference between the Area (% of total land area) in Arable land in 2004 and the Area (% of total land area) in Permanent crop land in 2005?
Make the answer very short. 4.04. What is the difference between the Area (% of total land area) in Terrestrial protected areas in 2004 and the Area (% of total land area) in Agricultural land in 2006?
Your response must be concise. -10.49. What is the difference between the Area (% of total land area) of Terrestrial protected areas in 2004 and the Area (% of total land area) of Arable land in 2006?
Make the answer very short. 0.27. What is the difference between the Area (% of total land area) in Terrestrial protected areas in 2004 and the Area (% of total land area) in Permanent crop land in 2006?
Give a very brief answer. 4.44. What is the difference between the Area (% of total land area) of Agricultural land in 2004 and the Area (% of total land area) of Arable land in 2006?
Your response must be concise. 10.63. What is the difference between the Area (% of total land area) in Agricultural land in 2004 and the Area (% of total land area) in Permanent crop land in 2006?
Your answer should be very brief. 14.79. What is the difference between the Area (% of total land area) in Arable land in 2004 and the Area (% of total land area) in Permanent crop land in 2006?
Your answer should be very brief. 4.04. What is the difference between the Area (% of total land area) in Terrestrial protected areas in 2004 and the Area (% of total land area) in Agricultural land in 2007?
Make the answer very short. -10.49. What is the difference between the Area (% of total land area) of Terrestrial protected areas in 2004 and the Area (% of total land area) of Arable land in 2007?
Give a very brief answer. 0.27. What is the difference between the Area (% of total land area) of Terrestrial protected areas in 2004 and the Area (% of total land area) of Permanent crop land in 2007?
Ensure brevity in your answer.  4.44. What is the difference between the Area (% of total land area) of Agricultural land in 2004 and the Area (% of total land area) of Arable land in 2007?
Keep it short and to the point. 10.63. What is the difference between the Area (% of total land area) in Agricultural land in 2004 and the Area (% of total land area) in Permanent crop land in 2007?
Provide a short and direct response. 14.79. What is the difference between the Area (% of total land area) of Arable land in 2004 and the Area (% of total land area) of Permanent crop land in 2007?
Provide a short and direct response. 4.04. What is the difference between the Area (% of total land area) of Terrestrial protected areas in 2004 and the Area (% of total land area) of Agricultural land in 2008?
Provide a short and direct response. -10.56. What is the difference between the Area (% of total land area) of Terrestrial protected areas in 2004 and the Area (% of total land area) of Arable land in 2008?
Ensure brevity in your answer.  0.2. What is the difference between the Area (% of total land area) in Terrestrial protected areas in 2004 and the Area (% of total land area) in Permanent crop land in 2008?
Provide a succinct answer. 4.44. What is the difference between the Area (% of total land area) of Agricultural land in 2004 and the Area (% of total land area) of Arable land in 2008?
Provide a short and direct response. 10.56. What is the difference between the Area (% of total land area) of Agricultural land in 2004 and the Area (% of total land area) of Permanent crop land in 2008?
Provide a short and direct response. 14.79. What is the difference between the Area (% of total land area) in Arable land in 2004 and the Area (% of total land area) in Permanent crop land in 2008?
Your answer should be compact. 4.04. What is the difference between the Area (% of total land area) of Terrestrial protected areas in 2005 and the Area (% of total land area) of Agricultural land in 2006?
Give a very brief answer. -10.49. What is the difference between the Area (% of total land area) of Terrestrial protected areas in 2005 and the Area (% of total land area) of Arable land in 2006?
Your response must be concise. 0.27. What is the difference between the Area (% of total land area) in Terrestrial protected areas in 2005 and the Area (% of total land area) in Permanent crop land in 2006?
Provide a succinct answer. 4.44. What is the difference between the Area (% of total land area) of Agricultural land in 2005 and the Area (% of total land area) of Arable land in 2006?
Ensure brevity in your answer.  10.63. What is the difference between the Area (% of total land area) of Agricultural land in 2005 and the Area (% of total land area) of Permanent crop land in 2006?
Ensure brevity in your answer.  14.79. What is the difference between the Area (% of total land area) in Arable land in 2005 and the Area (% of total land area) in Permanent crop land in 2006?
Offer a terse response. 4.04. What is the difference between the Area (% of total land area) in Terrestrial protected areas in 2005 and the Area (% of total land area) in Agricultural land in 2007?
Your response must be concise. -10.49. What is the difference between the Area (% of total land area) in Terrestrial protected areas in 2005 and the Area (% of total land area) in Arable land in 2007?
Keep it short and to the point. 0.27. What is the difference between the Area (% of total land area) of Terrestrial protected areas in 2005 and the Area (% of total land area) of Permanent crop land in 2007?
Ensure brevity in your answer.  4.44. What is the difference between the Area (% of total land area) in Agricultural land in 2005 and the Area (% of total land area) in Arable land in 2007?
Keep it short and to the point. 10.63. What is the difference between the Area (% of total land area) of Agricultural land in 2005 and the Area (% of total land area) of Permanent crop land in 2007?
Provide a short and direct response. 14.79. What is the difference between the Area (% of total land area) of Arable land in 2005 and the Area (% of total land area) of Permanent crop land in 2007?
Your answer should be very brief. 4.04. What is the difference between the Area (% of total land area) of Terrestrial protected areas in 2005 and the Area (% of total land area) of Agricultural land in 2008?
Offer a very short reply. -10.56. What is the difference between the Area (% of total land area) of Terrestrial protected areas in 2005 and the Area (% of total land area) of Arable land in 2008?
Your response must be concise. 0.2. What is the difference between the Area (% of total land area) of Terrestrial protected areas in 2005 and the Area (% of total land area) of Permanent crop land in 2008?
Provide a succinct answer. 4.44. What is the difference between the Area (% of total land area) of Agricultural land in 2005 and the Area (% of total land area) of Arable land in 2008?
Your answer should be compact. 10.56. What is the difference between the Area (% of total land area) in Agricultural land in 2005 and the Area (% of total land area) in Permanent crop land in 2008?
Ensure brevity in your answer.  14.79. What is the difference between the Area (% of total land area) in Arable land in 2005 and the Area (% of total land area) in Permanent crop land in 2008?
Your answer should be compact. 4.04. What is the difference between the Area (% of total land area) in Terrestrial protected areas in 2006 and the Area (% of total land area) in Agricultural land in 2007?
Provide a succinct answer. -10.49. What is the difference between the Area (% of total land area) of Terrestrial protected areas in 2006 and the Area (% of total land area) of Arable land in 2007?
Provide a short and direct response. 0.27. What is the difference between the Area (% of total land area) of Terrestrial protected areas in 2006 and the Area (% of total land area) of Permanent crop land in 2007?
Provide a succinct answer. 4.44. What is the difference between the Area (% of total land area) in Agricultural land in 2006 and the Area (% of total land area) in Arable land in 2007?
Provide a succinct answer. 10.76. What is the difference between the Area (% of total land area) of Agricultural land in 2006 and the Area (% of total land area) of Permanent crop land in 2007?
Your answer should be very brief. 14.93. What is the difference between the Area (% of total land area) of Arable land in 2006 and the Area (% of total land area) of Permanent crop land in 2007?
Ensure brevity in your answer.  4.17. What is the difference between the Area (% of total land area) in Terrestrial protected areas in 2006 and the Area (% of total land area) in Agricultural land in 2008?
Give a very brief answer. -10.56. What is the difference between the Area (% of total land area) in Terrestrial protected areas in 2006 and the Area (% of total land area) in Arable land in 2008?
Your response must be concise. 0.2. What is the difference between the Area (% of total land area) of Terrestrial protected areas in 2006 and the Area (% of total land area) of Permanent crop land in 2008?
Provide a succinct answer. 4.44. What is the difference between the Area (% of total land area) in Agricultural land in 2006 and the Area (% of total land area) in Arable land in 2008?
Offer a terse response. 10.69. What is the difference between the Area (% of total land area) of Agricultural land in 2006 and the Area (% of total land area) of Permanent crop land in 2008?
Give a very brief answer. 14.93. What is the difference between the Area (% of total land area) of Arable land in 2006 and the Area (% of total land area) of Permanent crop land in 2008?
Give a very brief answer. 4.17. What is the difference between the Area (% of total land area) of Terrestrial protected areas in 2007 and the Area (% of total land area) of Agricultural land in 2008?
Ensure brevity in your answer.  -9.62. What is the difference between the Area (% of total land area) in Terrestrial protected areas in 2007 and the Area (% of total land area) in Arable land in 2008?
Keep it short and to the point. 1.14. What is the difference between the Area (% of total land area) in Terrestrial protected areas in 2007 and the Area (% of total land area) in Permanent crop land in 2008?
Offer a very short reply. 5.38. What is the difference between the Area (% of total land area) of Agricultural land in 2007 and the Area (% of total land area) of Arable land in 2008?
Give a very brief answer. 10.69. What is the difference between the Area (% of total land area) in Agricultural land in 2007 and the Area (% of total land area) in Permanent crop land in 2008?
Keep it short and to the point. 14.93. What is the difference between the Area (% of total land area) of Arable land in 2007 and the Area (% of total land area) of Permanent crop land in 2008?
Make the answer very short. 4.17. What is the average Area (% of total land area) in Terrestrial protected areas per year?
Keep it short and to the point. 5.13. What is the average Area (% of total land area) of Agricultural land per year?
Make the answer very short. 15.52. What is the average Area (% of total land area) in Arable land per year?
Offer a very short reply. 4.76. What is the average Area (% of total land area) of Permanent crop land per year?
Give a very brief answer. 0.67. In the year 2000, what is the difference between the Area (% of total land area) in Terrestrial protected areas and Area (% of total land area) in Agricultural land?
Ensure brevity in your answer.  -12.08. In the year 2000, what is the difference between the Area (% of total land area) in Terrestrial protected areas and Area (% of total land area) in Arable land?
Provide a short and direct response. -1.32. In the year 2000, what is the difference between the Area (% of total land area) of Terrestrial protected areas and Area (% of total land area) of Permanent crop land?
Offer a very short reply. 2.71. In the year 2000, what is the difference between the Area (% of total land area) in Agricultural land and Area (% of total land area) in Arable land?
Offer a terse response. 10.76. In the year 2000, what is the difference between the Area (% of total land area) of Agricultural land and Area (% of total land area) of Permanent crop land?
Give a very brief answer. 14.79. In the year 2000, what is the difference between the Area (% of total land area) in Arable land and Area (% of total land area) in Permanent crop land?
Provide a short and direct response. 4.04. In the year 2001, what is the difference between the Area (% of total land area) in Terrestrial protected areas and Area (% of total land area) in Agricultural land?
Ensure brevity in your answer.  -10.36. In the year 2001, what is the difference between the Area (% of total land area) of Terrestrial protected areas and Area (% of total land area) of Arable land?
Offer a very short reply. 0.4. In the year 2001, what is the difference between the Area (% of total land area) in Terrestrial protected areas and Area (% of total land area) in Permanent crop land?
Your answer should be compact. 4.44. In the year 2001, what is the difference between the Area (% of total land area) of Agricultural land and Area (% of total land area) of Arable land?
Your answer should be very brief. 10.76. In the year 2001, what is the difference between the Area (% of total land area) in Agricultural land and Area (% of total land area) in Permanent crop land?
Keep it short and to the point. 14.79. In the year 2001, what is the difference between the Area (% of total land area) in Arable land and Area (% of total land area) in Permanent crop land?
Make the answer very short. 4.04. In the year 2002, what is the difference between the Area (% of total land area) in Terrestrial protected areas and Area (% of total land area) in Agricultural land?
Your answer should be compact. -10.36. In the year 2002, what is the difference between the Area (% of total land area) of Terrestrial protected areas and Area (% of total land area) of Arable land?
Give a very brief answer. 0.4. In the year 2002, what is the difference between the Area (% of total land area) in Terrestrial protected areas and Area (% of total land area) in Permanent crop land?
Keep it short and to the point. 4.44. In the year 2002, what is the difference between the Area (% of total land area) of Agricultural land and Area (% of total land area) of Arable land?
Provide a short and direct response. 10.76. In the year 2002, what is the difference between the Area (% of total land area) of Agricultural land and Area (% of total land area) of Permanent crop land?
Your answer should be very brief. 14.79. In the year 2002, what is the difference between the Area (% of total land area) of Arable land and Area (% of total land area) of Permanent crop land?
Your response must be concise. 4.04. In the year 2003, what is the difference between the Area (% of total land area) in Terrestrial protected areas and Area (% of total land area) in Agricultural land?
Give a very brief answer. -10.36. In the year 2003, what is the difference between the Area (% of total land area) in Terrestrial protected areas and Area (% of total land area) in Arable land?
Ensure brevity in your answer.  0.4. In the year 2003, what is the difference between the Area (% of total land area) in Terrestrial protected areas and Area (% of total land area) in Permanent crop land?
Give a very brief answer. 4.44. In the year 2003, what is the difference between the Area (% of total land area) in Agricultural land and Area (% of total land area) in Arable land?
Offer a very short reply. 10.76. In the year 2003, what is the difference between the Area (% of total land area) in Agricultural land and Area (% of total land area) in Permanent crop land?
Offer a very short reply. 14.79. In the year 2003, what is the difference between the Area (% of total land area) of Arable land and Area (% of total land area) of Permanent crop land?
Your answer should be very brief. 4.04. In the year 2004, what is the difference between the Area (% of total land area) in Terrestrial protected areas and Area (% of total land area) in Agricultural land?
Provide a succinct answer. -10.36. In the year 2004, what is the difference between the Area (% of total land area) in Terrestrial protected areas and Area (% of total land area) in Arable land?
Provide a short and direct response. 0.4. In the year 2004, what is the difference between the Area (% of total land area) in Terrestrial protected areas and Area (% of total land area) in Permanent crop land?
Make the answer very short. 4.44. In the year 2004, what is the difference between the Area (% of total land area) in Agricultural land and Area (% of total land area) in Arable land?
Your answer should be compact. 10.76. In the year 2004, what is the difference between the Area (% of total land area) in Agricultural land and Area (% of total land area) in Permanent crop land?
Offer a terse response. 14.79. In the year 2004, what is the difference between the Area (% of total land area) of Arable land and Area (% of total land area) of Permanent crop land?
Offer a terse response. 4.04. In the year 2005, what is the difference between the Area (% of total land area) of Terrestrial protected areas and Area (% of total land area) of Agricultural land?
Provide a succinct answer. -10.36. In the year 2005, what is the difference between the Area (% of total land area) of Terrestrial protected areas and Area (% of total land area) of Arable land?
Your response must be concise. 0.4. In the year 2005, what is the difference between the Area (% of total land area) of Terrestrial protected areas and Area (% of total land area) of Permanent crop land?
Keep it short and to the point. 4.44. In the year 2005, what is the difference between the Area (% of total land area) in Agricultural land and Area (% of total land area) in Arable land?
Ensure brevity in your answer.  10.76. In the year 2005, what is the difference between the Area (% of total land area) of Agricultural land and Area (% of total land area) of Permanent crop land?
Keep it short and to the point. 14.79. In the year 2005, what is the difference between the Area (% of total land area) in Arable land and Area (% of total land area) in Permanent crop land?
Your response must be concise. 4.04. In the year 2006, what is the difference between the Area (% of total land area) of Terrestrial protected areas and Area (% of total land area) of Agricultural land?
Provide a short and direct response. -10.49. In the year 2006, what is the difference between the Area (% of total land area) in Terrestrial protected areas and Area (% of total land area) in Arable land?
Provide a short and direct response. 0.27. In the year 2006, what is the difference between the Area (% of total land area) in Terrestrial protected areas and Area (% of total land area) in Permanent crop land?
Ensure brevity in your answer.  4.44. In the year 2006, what is the difference between the Area (% of total land area) in Agricultural land and Area (% of total land area) in Arable land?
Your answer should be very brief. 10.76. In the year 2006, what is the difference between the Area (% of total land area) of Agricultural land and Area (% of total land area) of Permanent crop land?
Your answer should be compact. 14.93. In the year 2006, what is the difference between the Area (% of total land area) of Arable land and Area (% of total land area) of Permanent crop land?
Keep it short and to the point. 4.17. In the year 2007, what is the difference between the Area (% of total land area) of Terrestrial protected areas and Area (% of total land area) of Agricultural land?
Your answer should be very brief. -9.55. In the year 2007, what is the difference between the Area (% of total land area) in Terrestrial protected areas and Area (% of total land area) in Arable land?
Your response must be concise. 1.21. In the year 2007, what is the difference between the Area (% of total land area) in Terrestrial protected areas and Area (% of total land area) in Permanent crop land?
Ensure brevity in your answer.  5.38. In the year 2007, what is the difference between the Area (% of total land area) of Agricultural land and Area (% of total land area) of Arable land?
Keep it short and to the point. 10.76. In the year 2007, what is the difference between the Area (% of total land area) of Agricultural land and Area (% of total land area) of Permanent crop land?
Offer a terse response. 14.93. In the year 2007, what is the difference between the Area (% of total land area) in Arable land and Area (% of total land area) in Permanent crop land?
Your answer should be very brief. 4.17. In the year 2008, what is the difference between the Area (% of total land area) of Terrestrial protected areas and Area (% of total land area) of Agricultural land?
Keep it short and to the point. -9.62. In the year 2008, what is the difference between the Area (% of total land area) of Terrestrial protected areas and Area (% of total land area) of Arable land?
Offer a terse response. 1.14. In the year 2008, what is the difference between the Area (% of total land area) in Terrestrial protected areas and Area (% of total land area) in Permanent crop land?
Your answer should be compact. 5.38. In the year 2008, what is the difference between the Area (% of total land area) in Agricultural land and Area (% of total land area) in Arable land?
Offer a very short reply. 10.76. In the year 2008, what is the difference between the Area (% of total land area) in Agricultural land and Area (% of total land area) in Permanent crop land?
Keep it short and to the point. 15. In the year 2008, what is the difference between the Area (% of total land area) in Arable land and Area (% of total land area) in Permanent crop land?
Your answer should be very brief. 4.24. What is the ratio of the Area (% of total land area) in Terrestrial protected areas in 2000 to that in 2001?
Keep it short and to the point. 0.66. What is the ratio of the Area (% of total land area) of Agricultural land in 2000 to that in 2001?
Your response must be concise. 1. What is the ratio of the Area (% of total land area) of Arable land in 2000 to that in 2001?
Your response must be concise. 1. What is the ratio of the Area (% of total land area) in Terrestrial protected areas in 2000 to that in 2002?
Your response must be concise. 0.66. What is the ratio of the Area (% of total land area) in Agricultural land in 2000 to that in 2002?
Offer a terse response. 1. What is the ratio of the Area (% of total land area) in Permanent crop land in 2000 to that in 2002?
Your answer should be compact. 1. What is the ratio of the Area (% of total land area) in Terrestrial protected areas in 2000 to that in 2003?
Make the answer very short. 0.66. What is the ratio of the Area (% of total land area) of Agricultural land in 2000 to that in 2003?
Offer a terse response. 1. What is the ratio of the Area (% of total land area) in Arable land in 2000 to that in 2003?
Ensure brevity in your answer.  1. What is the ratio of the Area (% of total land area) in Permanent crop land in 2000 to that in 2003?
Ensure brevity in your answer.  1. What is the ratio of the Area (% of total land area) in Terrestrial protected areas in 2000 to that in 2004?
Give a very brief answer. 0.66. What is the ratio of the Area (% of total land area) of Agricultural land in 2000 to that in 2004?
Offer a very short reply. 1. What is the ratio of the Area (% of total land area) of Arable land in 2000 to that in 2004?
Your answer should be compact. 1. What is the ratio of the Area (% of total land area) in Terrestrial protected areas in 2000 to that in 2005?
Offer a terse response. 0.66. What is the ratio of the Area (% of total land area) of Arable land in 2000 to that in 2005?
Your answer should be very brief. 1. What is the ratio of the Area (% of total land area) of Permanent crop land in 2000 to that in 2005?
Keep it short and to the point. 1. What is the ratio of the Area (% of total land area) of Terrestrial protected areas in 2000 to that in 2006?
Your answer should be very brief. 0.66. What is the ratio of the Area (% of total land area) in Arable land in 2000 to that in 2006?
Make the answer very short. 0.97. What is the ratio of the Area (% of total land area) of Terrestrial protected areas in 2000 to that in 2007?
Provide a short and direct response. 0.56. What is the ratio of the Area (% of total land area) of Agricultural land in 2000 to that in 2007?
Your answer should be compact. 0.99. What is the ratio of the Area (% of total land area) in Arable land in 2000 to that in 2007?
Offer a terse response. 0.97. What is the ratio of the Area (% of total land area) in Permanent crop land in 2000 to that in 2007?
Offer a very short reply. 1. What is the ratio of the Area (% of total land area) of Terrestrial protected areas in 2000 to that in 2008?
Keep it short and to the point. 0.56. What is the ratio of the Area (% of total land area) in Agricultural land in 2000 to that in 2008?
Provide a succinct answer. 0.99. What is the ratio of the Area (% of total land area) in Arable land in 2000 to that in 2008?
Keep it short and to the point. 0.96. What is the ratio of the Area (% of total land area) of Permanent crop land in 2000 to that in 2008?
Make the answer very short. 1. What is the ratio of the Area (% of total land area) in Agricultural land in 2001 to that in 2002?
Offer a very short reply. 1. What is the ratio of the Area (% of total land area) of Arable land in 2001 to that in 2002?
Make the answer very short. 1. What is the ratio of the Area (% of total land area) of Permanent crop land in 2001 to that in 2002?
Offer a very short reply. 1. What is the ratio of the Area (% of total land area) of Arable land in 2001 to that in 2003?
Your answer should be very brief. 1. What is the ratio of the Area (% of total land area) of Agricultural land in 2001 to that in 2004?
Provide a succinct answer. 1. What is the ratio of the Area (% of total land area) of Agricultural land in 2001 to that in 2005?
Your answer should be very brief. 1. What is the ratio of the Area (% of total land area) of Permanent crop land in 2001 to that in 2005?
Offer a terse response. 1. What is the ratio of the Area (% of total land area) of Agricultural land in 2001 to that in 2006?
Offer a very short reply. 0.99. What is the ratio of the Area (% of total land area) of Arable land in 2001 to that in 2006?
Provide a succinct answer. 0.97. What is the ratio of the Area (% of total land area) of Permanent crop land in 2001 to that in 2006?
Your answer should be very brief. 1. What is the ratio of the Area (% of total land area) of Terrestrial protected areas in 2001 to that in 2007?
Ensure brevity in your answer.  0.84. What is the ratio of the Area (% of total land area) of Agricultural land in 2001 to that in 2007?
Ensure brevity in your answer.  0.99. What is the ratio of the Area (% of total land area) in Arable land in 2001 to that in 2007?
Give a very brief answer. 0.97. What is the ratio of the Area (% of total land area) of Terrestrial protected areas in 2001 to that in 2008?
Keep it short and to the point. 0.84. What is the ratio of the Area (% of total land area) in Agricultural land in 2001 to that in 2008?
Make the answer very short. 0.99. What is the ratio of the Area (% of total land area) in Arable land in 2001 to that in 2008?
Your answer should be compact. 0.96. What is the ratio of the Area (% of total land area) of Terrestrial protected areas in 2002 to that in 2003?
Give a very brief answer. 1. What is the ratio of the Area (% of total land area) in Agricultural land in 2002 to that in 2003?
Make the answer very short. 1. What is the ratio of the Area (% of total land area) of Arable land in 2002 to that in 2003?
Provide a short and direct response. 1. What is the ratio of the Area (% of total land area) of Terrestrial protected areas in 2002 to that in 2004?
Give a very brief answer. 1. What is the ratio of the Area (% of total land area) in Agricultural land in 2002 to that in 2004?
Make the answer very short. 1. What is the ratio of the Area (% of total land area) in Permanent crop land in 2002 to that in 2004?
Your response must be concise. 1. What is the ratio of the Area (% of total land area) of Arable land in 2002 to that in 2005?
Offer a terse response. 1. What is the ratio of the Area (% of total land area) of Permanent crop land in 2002 to that in 2005?
Make the answer very short. 1. What is the ratio of the Area (% of total land area) of Agricultural land in 2002 to that in 2006?
Offer a terse response. 0.99. What is the ratio of the Area (% of total land area) of Arable land in 2002 to that in 2006?
Provide a short and direct response. 0.97. What is the ratio of the Area (% of total land area) in Permanent crop land in 2002 to that in 2006?
Your response must be concise. 1. What is the ratio of the Area (% of total land area) of Terrestrial protected areas in 2002 to that in 2007?
Ensure brevity in your answer.  0.84. What is the ratio of the Area (% of total land area) of Agricultural land in 2002 to that in 2007?
Offer a very short reply. 0.99. What is the ratio of the Area (% of total land area) in Arable land in 2002 to that in 2007?
Ensure brevity in your answer.  0.97. What is the ratio of the Area (% of total land area) of Terrestrial protected areas in 2002 to that in 2008?
Your answer should be very brief. 0.84. What is the ratio of the Area (% of total land area) in Agricultural land in 2002 to that in 2008?
Your answer should be very brief. 0.99. What is the ratio of the Area (% of total land area) of Arable land in 2002 to that in 2008?
Your answer should be very brief. 0.96. What is the ratio of the Area (% of total land area) of Agricultural land in 2003 to that in 2004?
Make the answer very short. 1. What is the ratio of the Area (% of total land area) in Permanent crop land in 2003 to that in 2004?
Offer a very short reply. 1. What is the ratio of the Area (% of total land area) of Terrestrial protected areas in 2003 to that in 2005?
Ensure brevity in your answer.  1. What is the ratio of the Area (% of total land area) in Arable land in 2003 to that in 2005?
Your response must be concise. 1. What is the ratio of the Area (% of total land area) in Arable land in 2003 to that in 2006?
Provide a short and direct response. 0.97. What is the ratio of the Area (% of total land area) in Terrestrial protected areas in 2003 to that in 2007?
Offer a terse response. 0.84. What is the ratio of the Area (% of total land area) of Agricultural land in 2003 to that in 2007?
Your answer should be compact. 0.99. What is the ratio of the Area (% of total land area) in Arable land in 2003 to that in 2007?
Provide a short and direct response. 0.97. What is the ratio of the Area (% of total land area) of Permanent crop land in 2003 to that in 2007?
Offer a terse response. 1. What is the ratio of the Area (% of total land area) of Terrestrial protected areas in 2003 to that in 2008?
Your answer should be compact. 0.84. What is the ratio of the Area (% of total land area) of Agricultural land in 2003 to that in 2008?
Keep it short and to the point. 0.99. What is the ratio of the Area (% of total land area) in Arable land in 2003 to that in 2008?
Your answer should be compact. 0.96. What is the ratio of the Area (% of total land area) in Arable land in 2004 to that in 2005?
Offer a terse response. 1. What is the ratio of the Area (% of total land area) of Terrestrial protected areas in 2004 to that in 2006?
Your answer should be very brief. 1. What is the ratio of the Area (% of total land area) of Arable land in 2004 to that in 2006?
Keep it short and to the point. 0.97. What is the ratio of the Area (% of total land area) of Terrestrial protected areas in 2004 to that in 2007?
Give a very brief answer. 0.84. What is the ratio of the Area (% of total land area) in Agricultural land in 2004 to that in 2007?
Your response must be concise. 0.99. What is the ratio of the Area (% of total land area) in Arable land in 2004 to that in 2007?
Ensure brevity in your answer.  0.97. What is the ratio of the Area (% of total land area) of Terrestrial protected areas in 2004 to that in 2008?
Your answer should be compact. 0.84. What is the ratio of the Area (% of total land area) in Agricultural land in 2004 to that in 2008?
Your answer should be compact. 0.99. What is the ratio of the Area (% of total land area) of Arable land in 2004 to that in 2008?
Ensure brevity in your answer.  0.96. What is the ratio of the Area (% of total land area) of Arable land in 2005 to that in 2006?
Make the answer very short. 0.97. What is the ratio of the Area (% of total land area) in Permanent crop land in 2005 to that in 2006?
Provide a succinct answer. 1. What is the ratio of the Area (% of total land area) in Terrestrial protected areas in 2005 to that in 2007?
Give a very brief answer. 0.84. What is the ratio of the Area (% of total land area) of Arable land in 2005 to that in 2007?
Provide a succinct answer. 0.97. What is the ratio of the Area (% of total land area) of Terrestrial protected areas in 2005 to that in 2008?
Make the answer very short. 0.84. What is the ratio of the Area (% of total land area) of Agricultural land in 2005 to that in 2008?
Ensure brevity in your answer.  0.99. What is the ratio of the Area (% of total land area) in Arable land in 2005 to that in 2008?
Ensure brevity in your answer.  0.96. What is the ratio of the Area (% of total land area) in Permanent crop land in 2005 to that in 2008?
Your answer should be very brief. 1. What is the ratio of the Area (% of total land area) in Terrestrial protected areas in 2006 to that in 2007?
Keep it short and to the point. 0.84. What is the ratio of the Area (% of total land area) in Arable land in 2006 to that in 2007?
Ensure brevity in your answer.  1. What is the ratio of the Area (% of total land area) of Terrestrial protected areas in 2006 to that in 2008?
Offer a very short reply. 0.84. What is the ratio of the Area (% of total land area) in Agricultural land in 2006 to that in 2008?
Provide a succinct answer. 1. What is the ratio of the Area (% of total land area) in Arable land in 2006 to that in 2008?
Provide a short and direct response. 0.99. What is the ratio of the Area (% of total land area) of Permanent crop land in 2006 to that in 2008?
Your answer should be compact. 1. What is the ratio of the Area (% of total land area) in Agricultural land in 2007 to that in 2008?
Offer a terse response. 1. What is the ratio of the Area (% of total land area) of Arable land in 2007 to that in 2008?
Your answer should be very brief. 0.99. What is the ratio of the Area (% of total land area) of Permanent crop land in 2007 to that in 2008?
Provide a succinct answer. 1. What is the difference between the highest and the second highest Area (% of total land area) of Terrestrial protected areas?
Your answer should be compact. 0. What is the difference between the highest and the second highest Area (% of total land area) of Agricultural land?
Offer a terse response. 0.07. What is the difference between the highest and the second highest Area (% of total land area) of Arable land?
Offer a very short reply. 0.07. What is the difference between the highest and the lowest Area (% of total land area) of Terrestrial protected areas?
Keep it short and to the point. 2.67. What is the difference between the highest and the lowest Area (% of total land area) in Agricultural land?
Offer a terse response. 0.2. What is the difference between the highest and the lowest Area (% of total land area) of Arable land?
Provide a succinct answer. 0.2. 